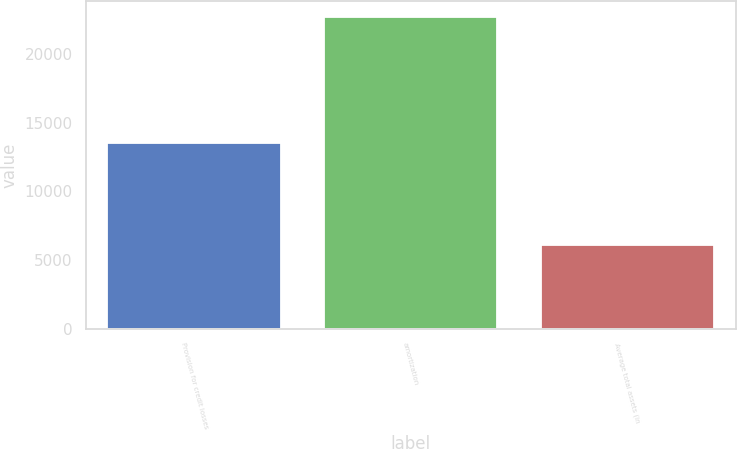<chart> <loc_0><loc_0><loc_500><loc_500><bar_chart><fcel>Provision for credit losses<fcel>amortization<fcel>Average total assets (in<nl><fcel>13513<fcel>22709<fcel>6110<nl></chart> 